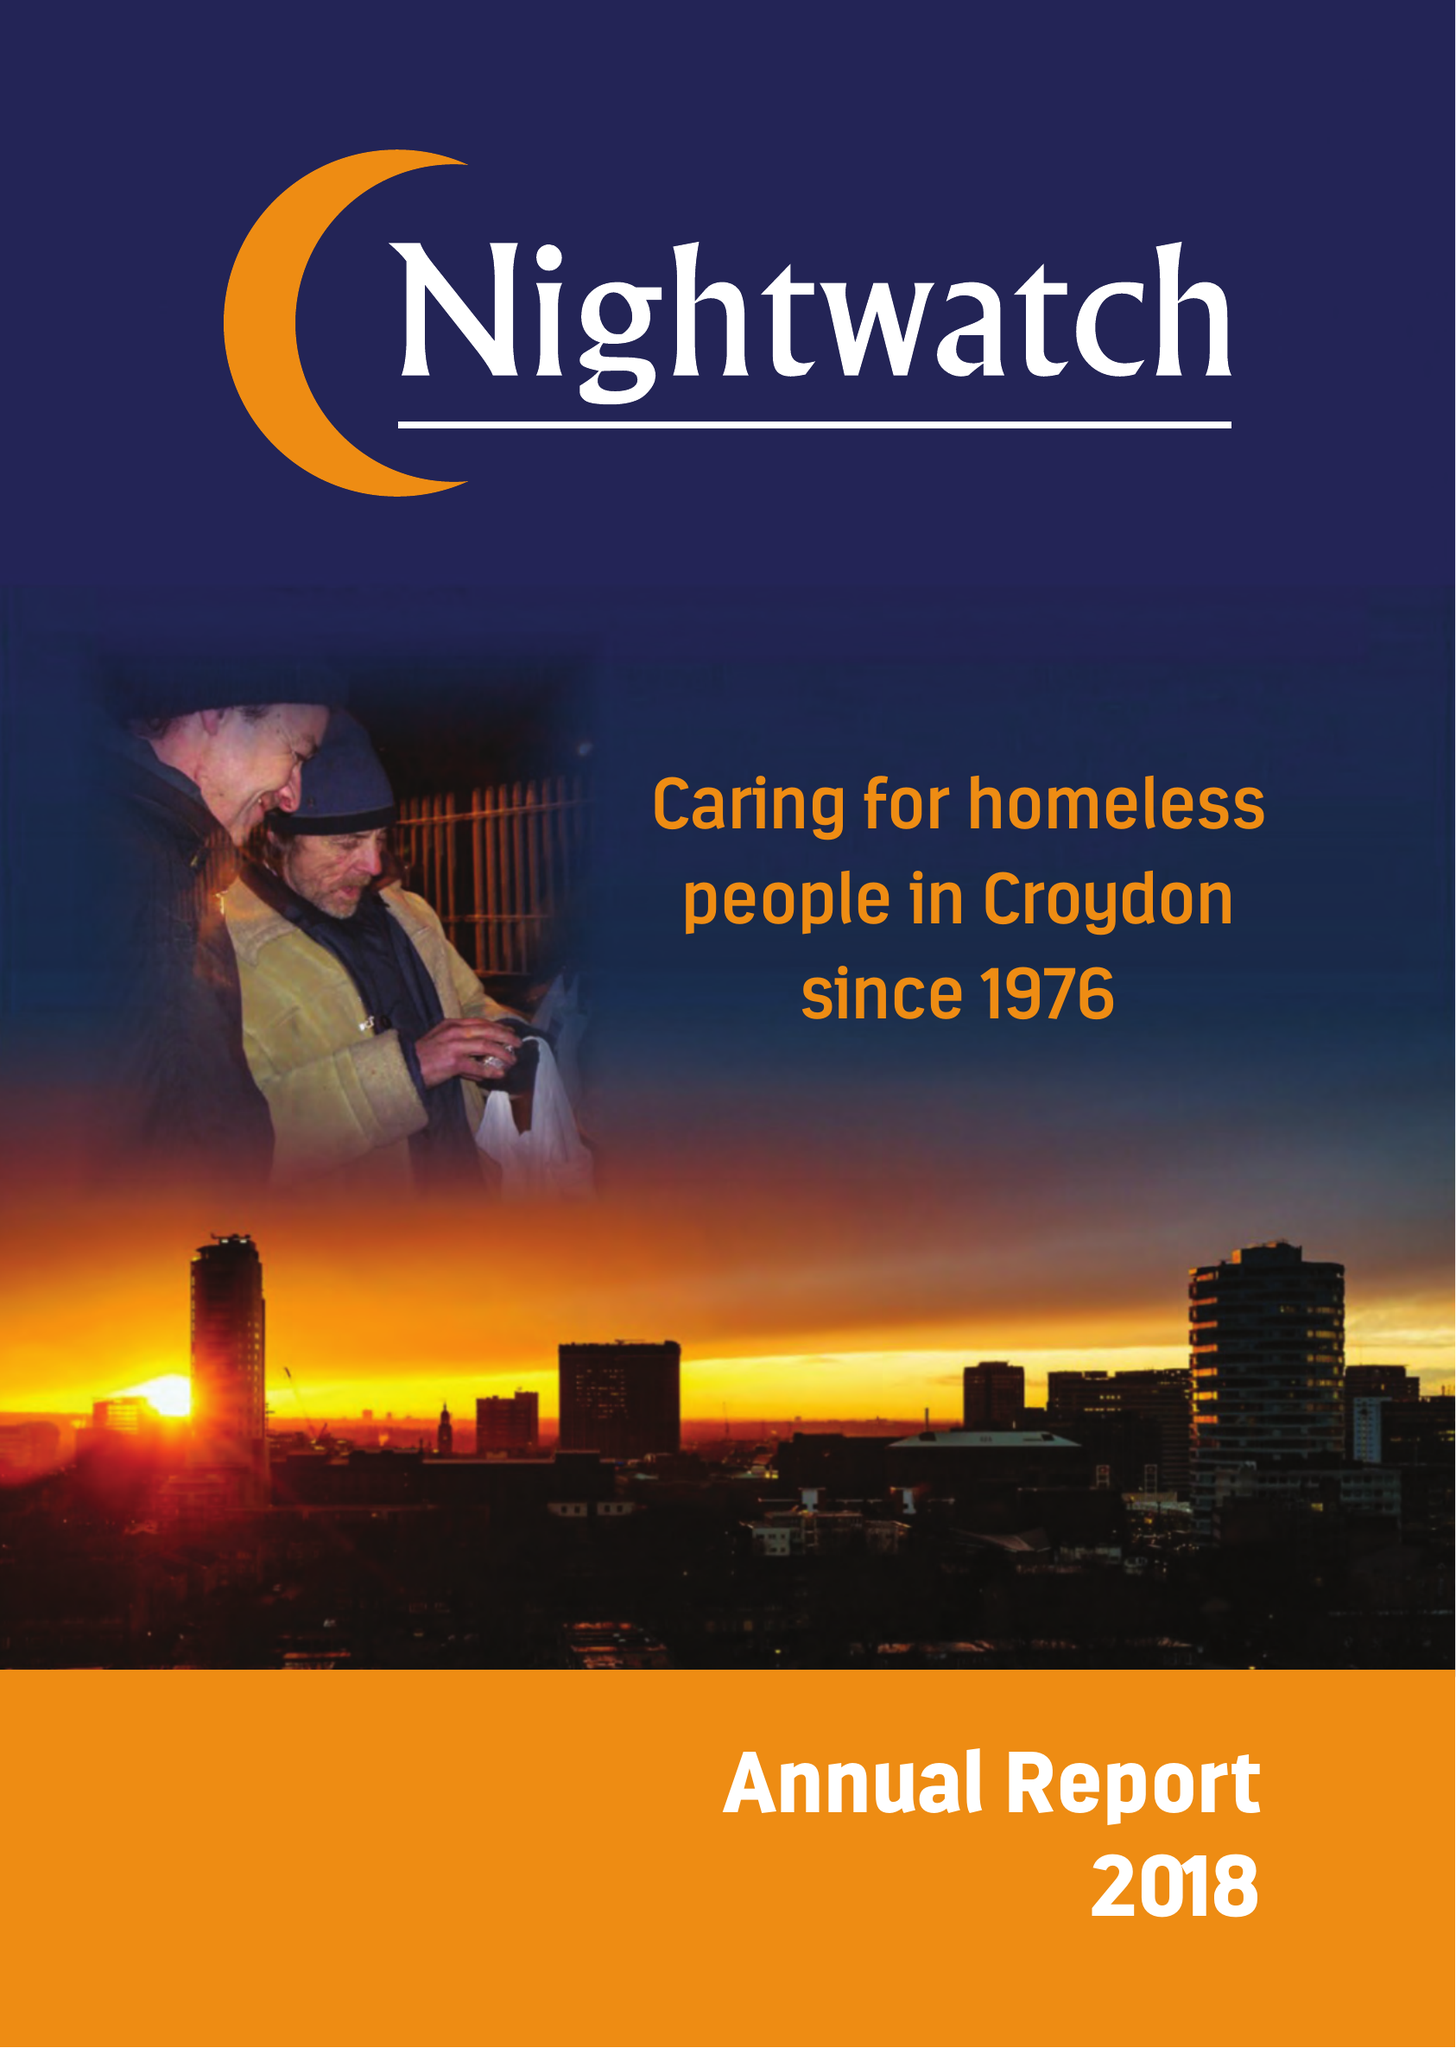What is the value for the address__postcode?
Answer the question using a single word or phrase. SE23 3ZH 